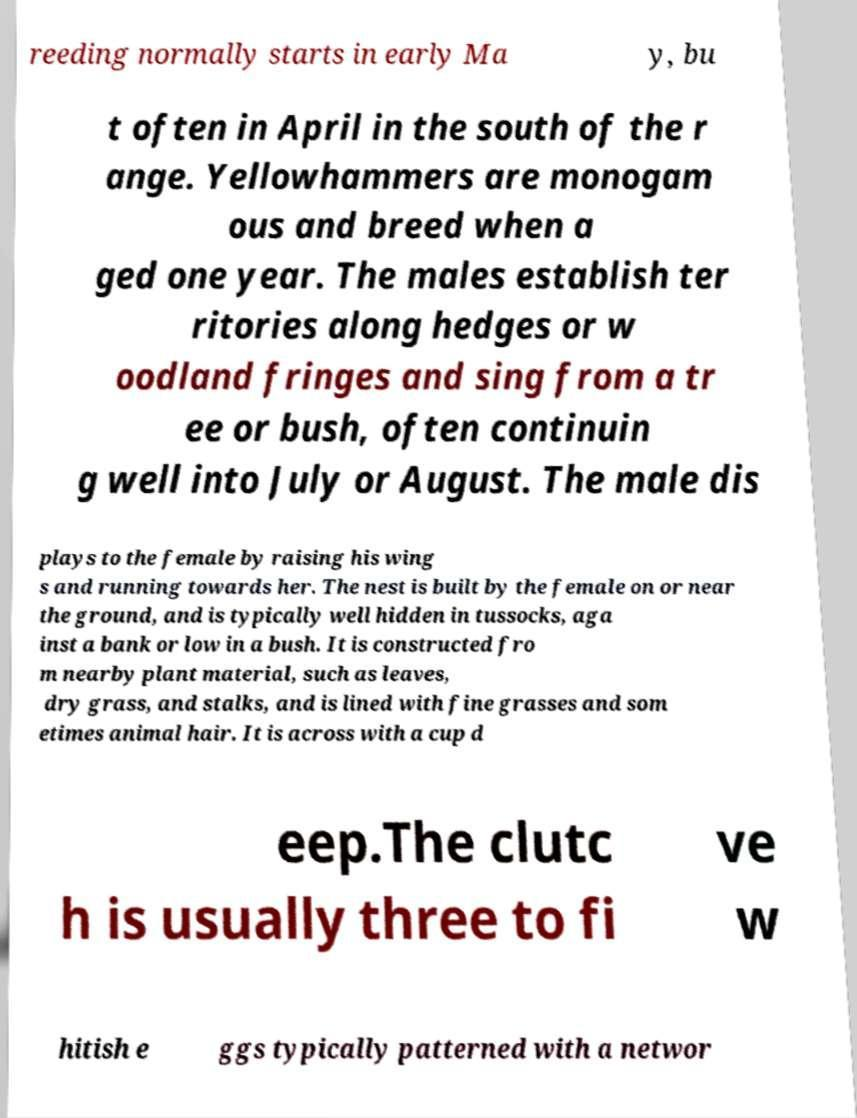Could you assist in decoding the text presented in this image and type it out clearly? reeding normally starts in early Ma y, bu t often in April in the south of the r ange. Yellowhammers are monogam ous and breed when a ged one year. The males establish ter ritories along hedges or w oodland fringes and sing from a tr ee or bush, often continuin g well into July or August. The male dis plays to the female by raising his wing s and running towards her. The nest is built by the female on or near the ground, and is typically well hidden in tussocks, aga inst a bank or low in a bush. It is constructed fro m nearby plant material, such as leaves, dry grass, and stalks, and is lined with fine grasses and som etimes animal hair. It is across with a cup d eep.The clutc h is usually three to fi ve w hitish e ggs typically patterned with a networ 